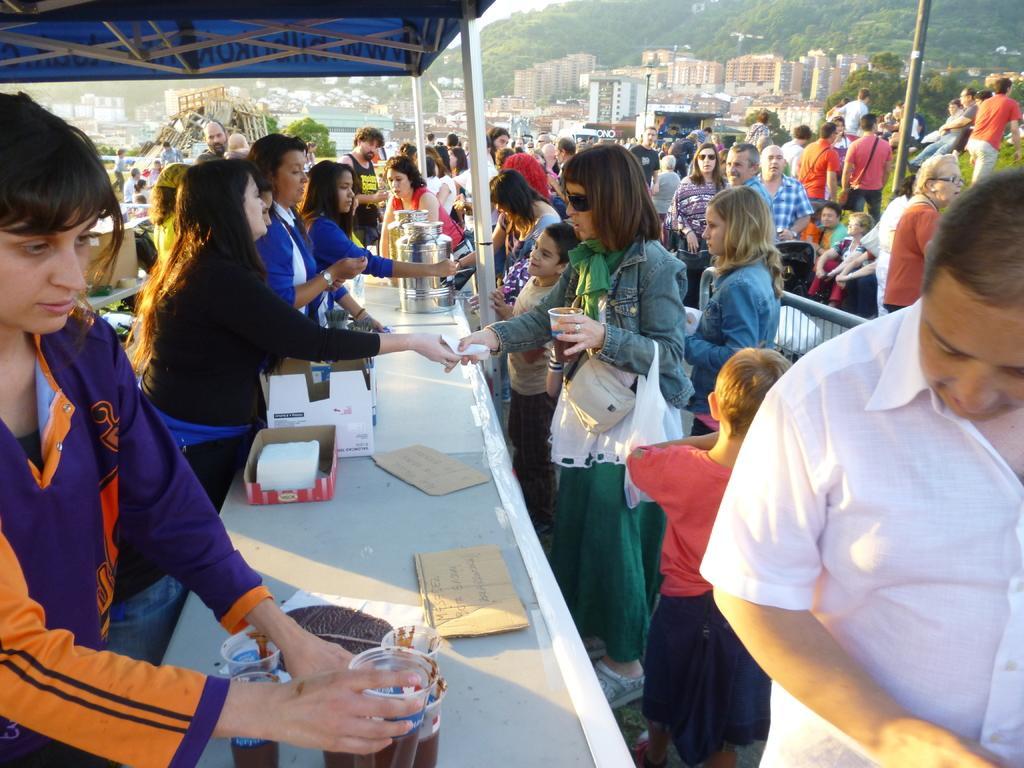Describe this image in one or two sentences. In this picture we can see trees, buildings, people, railing, objects, poles, beams and stalls. On the left side of the picture on a platform we can see boards with some information. We can see boxes, liquids in the glasses. 